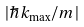<formula> <loc_0><loc_0><loc_500><loc_500>| \hbar { k } _ { \max } / m |</formula> 